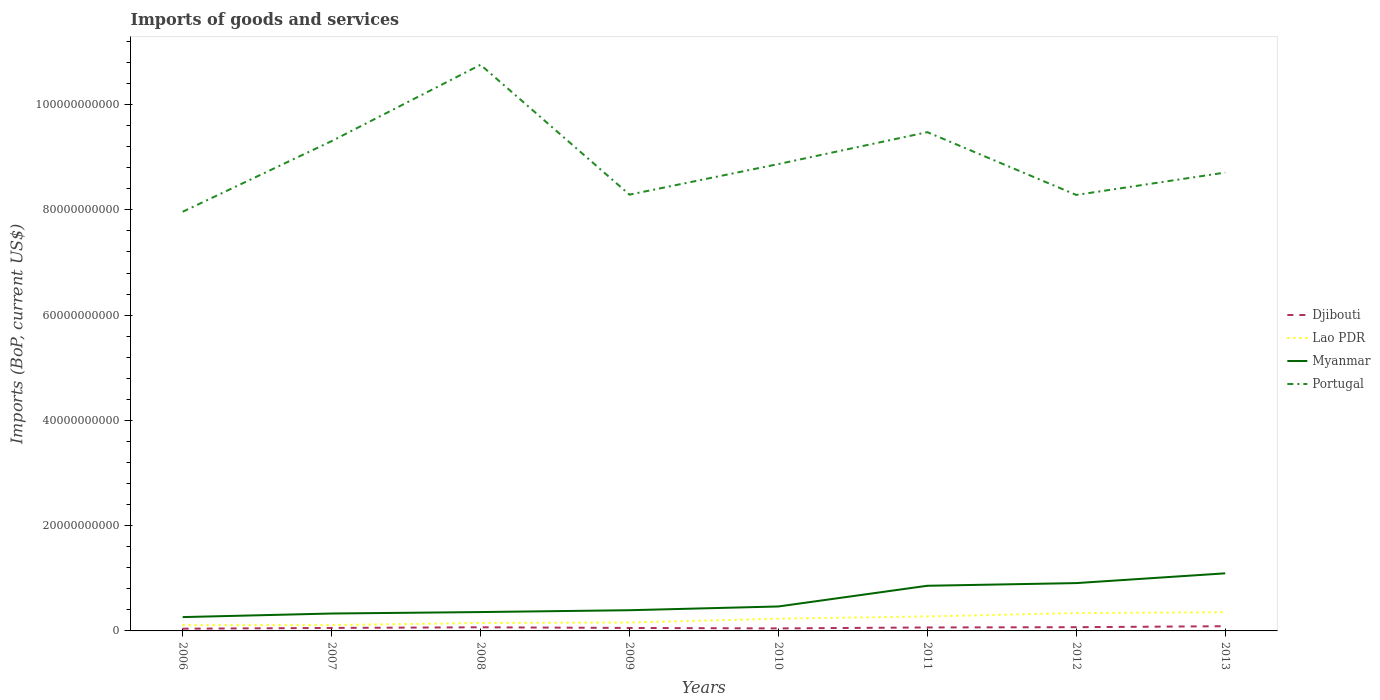How many different coloured lines are there?
Make the answer very short. 4. Does the line corresponding to Djibouti intersect with the line corresponding to Portugal?
Your response must be concise. No. Across all years, what is the maximum amount spent on imports in Portugal?
Offer a terse response. 7.96e+1. What is the total amount spent on imports in Lao PDR in the graph?
Provide a succinct answer. -2.46e+09. What is the difference between the highest and the second highest amount spent on imports in Djibouti?
Offer a terse response. 4.73e+08. What is the difference between the highest and the lowest amount spent on imports in Lao PDR?
Provide a succinct answer. 4. Is the amount spent on imports in Lao PDR strictly greater than the amount spent on imports in Portugal over the years?
Provide a short and direct response. Yes. How many lines are there?
Give a very brief answer. 4. How many years are there in the graph?
Offer a terse response. 8. What is the difference between two consecutive major ticks on the Y-axis?
Make the answer very short. 2.00e+1. Are the values on the major ticks of Y-axis written in scientific E-notation?
Give a very brief answer. No. Does the graph contain any zero values?
Provide a succinct answer. No. Where does the legend appear in the graph?
Offer a very short reply. Center right. How many legend labels are there?
Your response must be concise. 4. What is the title of the graph?
Offer a terse response. Imports of goods and services. Does "Isle of Man" appear as one of the legend labels in the graph?
Keep it short and to the point. No. What is the label or title of the Y-axis?
Provide a succinct answer. Imports (BoP, current US$). What is the Imports (BoP, current US$) of Djibouti in 2006?
Your answer should be compact. 4.25e+08. What is the Imports (BoP, current US$) of Lao PDR in 2006?
Ensure brevity in your answer.  1.10e+09. What is the Imports (BoP, current US$) of Myanmar in 2006?
Your answer should be compact. 2.63e+09. What is the Imports (BoP, current US$) in Portugal in 2006?
Offer a terse response. 7.96e+1. What is the Imports (BoP, current US$) in Djibouti in 2007?
Provide a succinct answer. 5.69e+08. What is the Imports (BoP, current US$) of Lao PDR in 2007?
Your answer should be very brief. 1.11e+09. What is the Imports (BoP, current US$) of Myanmar in 2007?
Make the answer very short. 3.31e+09. What is the Imports (BoP, current US$) in Portugal in 2007?
Your answer should be compact. 9.31e+1. What is the Imports (BoP, current US$) in Djibouti in 2008?
Your answer should be very brief. 6.91e+08. What is the Imports (BoP, current US$) of Lao PDR in 2008?
Offer a very short reply. 1.51e+09. What is the Imports (BoP, current US$) in Myanmar in 2008?
Your answer should be very brief. 3.58e+09. What is the Imports (BoP, current US$) of Portugal in 2008?
Offer a very short reply. 1.08e+11. What is the Imports (BoP, current US$) in Djibouti in 2009?
Make the answer very short. 5.65e+08. What is the Imports (BoP, current US$) in Lao PDR in 2009?
Your answer should be very brief. 1.60e+09. What is the Imports (BoP, current US$) of Myanmar in 2009?
Ensure brevity in your answer.  3.93e+09. What is the Imports (BoP, current US$) of Portugal in 2009?
Your response must be concise. 8.29e+1. What is the Imports (BoP, current US$) of Djibouti in 2010?
Keep it short and to the point. 4.78e+08. What is the Imports (BoP, current US$) in Lao PDR in 2010?
Ensure brevity in your answer.  2.32e+09. What is the Imports (BoP, current US$) of Myanmar in 2010?
Ensure brevity in your answer.  4.65e+09. What is the Imports (BoP, current US$) of Portugal in 2010?
Make the answer very short. 8.87e+1. What is the Imports (BoP, current US$) in Djibouti in 2011?
Keep it short and to the point. 6.58e+08. What is the Imports (BoP, current US$) in Lao PDR in 2011?
Keep it short and to the point. 2.75e+09. What is the Imports (BoP, current US$) of Myanmar in 2011?
Make the answer very short. 8.58e+09. What is the Imports (BoP, current US$) of Portugal in 2011?
Your response must be concise. 9.48e+1. What is the Imports (BoP, current US$) in Djibouti in 2012?
Give a very brief answer. 7.09e+08. What is the Imports (BoP, current US$) of Lao PDR in 2012?
Keep it short and to the point. 3.39e+09. What is the Imports (BoP, current US$) of Myanmar in 2012?
Offer a terse response. 9.09e+09. What is the Imports (BoP, current US$) of Portugal in 2012?
Offer a terse response. 8.28e+1. What is the Imports (BoP, current US$) of Djibouti in 2013?
Provide a short and direct response. 8.98e+08. What is the Imports (BoP, current US$) in Lao PDR in 2013?
Provide a short and direct response. 3.55e+09. What is the Imports (BoP, current US$) in Myanmar in 2013?
Ensure brevity in your answer.  1.09e+1. What is the Imports (BoP, current US$) in Portugal in 2013?
Provide a succinct answer. 8.71e+1. Across all years, what is the maximum Imports (BoP, current US$) of Djibouti?
Offer a very short reply. 8.98e+08. Across all years, what is the maximum Imports (BoP, current US$) of Lao PDR?
Make the answer very short. 3.55e+09. Across all years, what is the maximum Imports (BoP, current US$) in Myanmar?
Your answer should be compact. 1.09e+1. Across all years, what is the maximum Imports (BoP, current US$) in Portugal?
Provide a succinct answer. 1.08e+11. Across all years, what is the minimum Imports (BoP, current US$) of Djibouti?
Offer a terse response. 4.25e+08. Across all years, what is the minimum Imports (BoP, current US$) in Lao PDR?
Provide a succinct answer. 1.10e+09. Across all years, what is the minimum Imports (BoP, current US$) of Myanmar?
Offer a terse response. 2.63e+09. Across all years, what is the minimum Imports (BoP, current US$) of Portugal?
Give a very brief answer. 7.96e+1. What is the total Imports (BoP, current US$) in Djibouti in the graph?
Offer a very short reply. 4.99e+09. What is the total Imports (BoP, current US$) of Lao PDR in the graph?
Give a very brief answer. 1.73e+1. What is the total Imports (BoP, current US$) of Myanmar in the graph?
Provide a succinct answer. 4.67e+1. What is the total Imports (BoP, current US$) of Portugal in the graph?
Your answer should be very brief. 7.17e+11. What is the difference between the Imports (BoP, current US$) in Djibouti in 2006 and that in 2007?
Keep it short and to the point. -1.44e+08. What is the difference between the Imports (BoP, current US$) of Lao PDR in 2006 and that in 2007?
Keep it short and to the point. -1.08e+07. What is the difference between the Imports (BoP, current US$) of Myanmar in 2006 and that in 2007?
Your response must be concise. -6.80e+08. What is the difference between the Imports (BoP, current US$) of Portugal in 2006 and that in 2007?
Provide a short and direct response. -1.34e+1. What is the difference between the Imports (BoP, current US$) in Djibouti in 2006 and that in 2008?
Make the answer very short. -2.66e+08. What is the difference between the Imports (BoP, current US$) in Lao PDR in 2006 and that in 2008?
Ensure brevity in your answer.  -4.13e+08. What is the difference between the Imports (BoP, current US$) of Myanmar in 2006 and that in 2008?
Your answer should be compact. -9.56e+08. What is the difference between the Imports (BoP, current US$) of Portugal in 2006 and that in 2008?
Make the answer very short. -2.79e+1. What is the difference between the Imports (BoP, current US$) in Djibouti in 2006 and that in 2009?
Ensure brevity in your answer.  -1.40e+08. What is the difference between the Imports (BoP, current US$) of Lao PDR in 2006 and that in 2009?
Your answer should be compact. -4.99e+08. What is the difference between the Imports (BoP, current US$) in Myanmar in 2006 and that in 2009?
Offer a terse response. -1.31e+09. What is the difference between the Imports (BoP, current US$) of Portugal in 2006 and that in 2009?
Ensure brevity in your answer.  -3.25e+09. What is the difference between the Imports (BoP, current US$) of Djibouti in 2006 and that in 2010?
Make the answer very short. -5.34e+07. What is the difference between the Imports (BoP, current US$) of Lao PDR in 2006 and that in 2010?
Make the answer very short. -1.23e+09. What is the difference between the Imports (BoP, current US$) in Myanmar in 2006 and that in 2010?
Provide a succinct answer. -2.02e+09. What is the difference between the Imports (BoP, current US$) in Portugal in 2006 and that in 2010?
Your answer should be very brief. -9.06e+09. What is the difference between the Imports (BoP, current US$) in Djibouti in 2006 and that in 2011?
Offer a terse response. -2.33e+08. What is the difference between the Imports (BoP, current US$) in Lao PDR in 2006 and that in 2011?
Provide a succinct answer. -1.66e+09. What is the difference between the Imports (BoP, current US$) of Myanmar in 2006 and that in 2011?
Offer a terse response. -5.95e+09. What is the difference between the Imports (BoP, current US$) of Portugal in 2006 and that in 2011?
Ensure brevity in your answer.  -1.51e+1. What is the difference between the Imports (BoP, current US$) in Djibouti in 2006 and that in 2012?
Keep it short and to the point. -2.84e+08. What is the difference between the Imports (BoP, current US$) of Lao PDR in 2006 and that in 2012?
Provide a short and direct response. -2.30e+09. What is the difference between the Imports (BoP, current US$) of Myanmar in 2006 and that in 2012?
Make the answer very short. -6.46e+09. What is the difference between the Imports (BoP, current US$) in Portugal in 2006 and that in 2012?
Your response must be concise. -3.19e+09. What is the difference between the Imports (BoP, current US$) in Djibouti in 2006 and that in 2013?
Your answer should be very brief. -4.73e+08. What is the difference between the Imports (BoP, current US$) of Lao PDR in 2006 and that in 2013?
Keep it short and to the point. -2.46e+09. What is the difference between the Imports (BoP, current US$) in Myanmar in 2006 and that in 2013?
Ensure brevity in your answer.  -8.32e+09. What is the difference between the Imports (BoP, current US$) of Portugal in 2006 and that in 2013?
Make the answer very short. -7.44e+09. What is the difference between the Imports (BoP, current US$) of Djibouti in 2007 and that in 2008?
Make the answer very short. -1.22e+08. What is the difference between the Imports (BoP, current US$) in Lao PDR in 2007 and that in 2008?
Your answer should be compact. -4.03e+08. What is the difference between the Imports (BoP, current US$) in Myanmar in 2007 and that in 2008?
Offer a very short reply. -2.76e+08. What is the difference between the Imports (BoP, current US$) of Portugal in 2007 and that in 2008?
Give a very brief answer. -1.45e+1. What is the difference between the Imports (BoP, current US$) in Djibouti in 2007 and that in 2009?
Your answer should be very brief. 3.92e+06. What is the difference between the Imports (BoP, current US$) in Lao PDR in 2007 and that in 2009?
Your answer should be very brief. -4.88e+08. What is the difference between the Imports (BoP, current US$) of Myanmar in 2007 and that in 2009?
Give a very brief answer. -6.26e+08. What is the difference between the Imports (BoP, current US$) of Portugal in 2007 and that in 2009?
Offer a terse response. 1.02e+1. What is the difference between the Imports (BoP, current US$) in Djibouti in 2007 and that in 2010?
Offer a very short reply. 9.02e+07. What is the difference between the Imports (BoP, current US$) in Lao PDR in 2007 and that in 2010?
Make the answer very short. -1.22e+09. What is the difference between the Imports (BoP, current US$) of Myanmar in 2007 and that in 2010?
Make the answer very short. -1.34e+09. What is the difference between the Imports (BoP, current US$) in Portugal in 2007 and that in 2010?
Ensure brevity in your answer.  4.36e+09. What is the difference between the Imports (BoP, current US$) in Djibouti in 2007 and that in 2011?
Offer a very short reply. -8.98e+07. What is the difference between the Imports (BoP, current US$) in Lao PDR in 2007 and that in 2011?
Make the answer very short. -1.65e+09. What is the difference between the Imports (BoP, current US$) in Myanmar in 2007 and that in 2011?
Give a very brief answer. -5.27e+09. What is the difference between the Imports (BoP, current US$) of Portugal in 2007 and that in 2011?
Offer a terse response. -1.70e+09. What is the difference between the Imports (BoP, current US$) of Djibouti in 2007 and that in 2012?
Your answer should be compact. -1.40e+08. What is the difference between the Imports (BoP, current US$) in Lao PDR in 2007 and that in 2012?
Your answer should be compact. -2.29e+09. What is the difference between the Imports (BoP, current US$) in Myanmar in 2007 and that in 2012?
Make the answer very short. -5.78e+09. What is the difference between the Imports (BoP, current US$) of Portugal in 2007 and that in 2012?
Your answer should be compact. 1.02e+1. What is the difference between the Imports (BoP, current US$) in Djibouti in 2007 and that in 2013?
Offer a terse response. -3.29e+08. What is the difference between the Imports (BoP, current US$) in Lao PDR in 2007 and that in 2013?
Your answer should be very brief. -2.44e+09. What is the difference between the Imports (BoP, current US$) of Myanmar in 2007 and that in 2013?
Your response must be concise. -7.64e+09. What is the difference between the Imports (BoP, current US$) in Portugal in 2007 and that in 2013?
Provide a succinct answer. 5.98e+09. What is the difference between the Imports (BoP, current US$) of Djibouti in 2008 and that in 2009?
Provide a short and direct response. 1.26e+08. What is the difference between the Imports (BoP, current US$) of Lao PDR in 2008 and that in 2009?
Give a very brief answer. -8.56e+07. What is the difference between the Imports (BoP, current US$) of Myanmar in 2008 and that in 2009?
Provide a succinct answer. -3.50e+08. What is the difference between the Imports (BoP, current US$) of Portugal in 2008 and that in 2009?
Your answer should be compact. 2.47e+1. What is the difference between the Imports (BoP, current US$) of Djibouti in 2008 and that in 2010?
Ensure brevity in your answer.  2.12e+08. What is the difference between the Imports (BoP, current US$) of Lao PDR in 2008 and that in 2010?
Give a very brief answer. -8.12e+08. What is the difference between the Imports (BoP, current US$) of Myanmar in 2008 and that in 2010?
Provide a short and direct response. -1.06e+09. What is the difference between the Imports (BoP, current US$) of Portugal in 2008 and that in 2010?
Offer a very short reply. 1.89e+1. What is the difference between the Imports (BoP, current US$) of Djibouti in 2008 and that in 2011?
Your response must be concise. 3.23e+07. What is the difference between the Imports (BoP, current US$) of Lao PDR in 2008 and that in 2011?
Ensure brevity in your answer.  -1.24e+09. What is the difference between the Imports (BoP, current US$) in Myanmar in 2008 and that in 2011?
Provide a short and direct response. -5.00e+09. What is the difference between the Imports (BoP, current US$) of Portugal in 2008 and that in 2011?
Ensure brevity in your answer.  1.28e+1. What is the difference between the Imports (BoP, current US$) in Djibouti in 2008 and that in 2012?
Offer a terse response. -1.84e+07. What is the difference between the Imports (BoP, current US$) of Lao PDR in 2008 and that in 2012?
Ensure brevity in your answer.  -1.88e+09. What is the difference between the Imports (BoP, current US$) in Myanmar in 2008 and that in 2012?
Give a very brief answer. -5.51e+09. What is the difference between the Imports (BoP, current US$) in Portugal in 2008 and that in 2012?
Ensure brevity in your answer.  2.47e+1. What is the difference between the Imports (BoP, current US$) of Djibouti in 2008 and that in 2013?
Offer a very short reply. -2.07e+08. What is the difference between the Imports (BoP, current US$) in Lao PDR in 2008 and that in 2013?
Your response must be concise. -2.04e+09. What is the difference between the Imports (BoP, current US$) in Myanmar in 2008 and that in 2013?
Your answer should be compact. -7.36e+09. What is the difference between the Imports (BoP, current US$) in Portugal in 2008 and that in 2013?
Your response must be concise. 2.05e+1. What is the difference between the Imports (BoP, current US$) of Djibouti in 2009 and that in 2010?
Offer a terse response. 8.62e+07. What is the difference between the Imports (BoP, current US$) in Lao PDR in 2009 and that in 2010?
Provide a short and direct response. -7.27e+08. What is the difference between the Imports (BoP, current US$) in Myanmar in 2009 and that in 2010?
Make the answer very short. -7.14e+08. What is the difference between the Imports (BoP, current US$) of Portugal in 2009 and that in 2010?
Keep it short and to the point. -5.81e+09. What is the difference between the Imports (BoP, current US$) in Djibouti in 2009 and that in 2011?
Provide a short and direct response. -9.37e+07. What is the difference between the Imports (BoP, current US$) of Lao PDR in 2009 and that in 2011?
Make the answer very short. -1.16e+09. What is the difference between the Imports (BoP, current US$) in Myanmar in 2009 and that in 2011?
Provide a succinct answer. -4.65e+09. What is the difference between the Imports (BoP, current US$) of Portugal in 2009 and that in 2011?
Provide a short and direct response. -1.19e+1. What is the difference between the Imports (BoP, current US$) in Djibouti in 2009 and that in 2012?
Provide a succinct answer. -1.44e+08. What is the difference between the Imports (BoP, current US$) in Lao PDR in 2009 and that in 2012?
Make the answer very short. -1.80e+09. What is the difference between the Imports (BoP, current US$) in Myanmar in 2009 and that in 2012?
Offer a very short reply. -5.16e+09. What is the difference between the Imports (BoP, current US$) in Portugal in 2009 and that in 2012?
Your answer should be very brief. 5.46e+07. What is the difference between the Imports (BoP, current US$) in Djibouti in 2009 and that in 2013?
Your answer should be very brief. -3.33e+08. What is the difference between the Imports (BoP, current US$) in Lao PDR in 2009 and that in 2013?
Keep it short and to the point. -1.96e+09. What is the difference between the Imports (BoP, current US$) of Myanmar in 2009 and that in 2013?
Your response must be concise. -7.01e+09. What is the difference between the Imports (BoP, current US$) of Portugal in 2009 and that in 2013?
Provide a short and direct response. -4.20e+09. What is the difference between the Imports (BoP, current US$) of Djibouti in 2010 and that in 2011?
Provide a succinct answer. -1.80e+08. What is the difference between the Imports (BoP, current US$) of Lao PDR in 2010 and that in 2011?
Provide a succinct answer. -4.30e+08. What is the difference between the Imports (BoP, current US$) of Myanmar in 2010 and that in 2011?
Give a very brief answer. -3.93e+09. What is the difference between the Imports (BoP, current US$) of Portugal in 2010 and that in 2011?
Offer a terse response. -6.06e+09. What is the difference between the Imports (BoP, current US$) of Djibouti in 2010 and that in 2012?
Offer a very short reply. -2.31e+08. What is the difference between the Imports (BoP, current US$) in Lao PDR in 2010 and that in 2012?
Your response must be concise. -1.07e+09. What is the difference between the Imports (BoP, current US$) in Myanmar in 2010 and that in 2012?
Offer a very short reply. -4.44e+09. What is the difference between the Imports (BoP, current US$) of Portugal in 2010 and that in 2012?
Offer a very short reply. 5.87e+09. What is the difference between the Imports (BoP, current US$) of Djibouti in 2010 and that in 2013?
Keep it short and to the point. -4.19e+08. What is the difference between the Imports (BoP, current US$) of Lao PDR in 2010 and that in 2013?
Give a very brief answer. -1.23e+09. What is the difference between the Imports (BoP, current US$) of Myanmar in 2010 and that in 2013?
Offer a terse response. -6.30e+09. What is the difference between the Imports (BoP, current US$) of Portugal in 2010 and that in 2013?
Ensure brevity in your answer.  1.62e+09. What is the difference between the Imports (BoP, current US$) of Djibouti in 2011 and that in 2012?
Ensure brevity in your answer.  -5.07e+07. What is the difference between the Imports (BoP, current US$) of Lao PDR in 2011 and that in 2012?
Provide a short and direct response. -6.41e+08. What is the difference between the Imports (BoP, current US$) in Myanmar in 2011 and that in 2012?
Your answer should be very brief. -5.07e+08. What is the difference between the Imports (BoP, current US$) in Portugal in 2011 and that in 2012?
Offer a terse response. 1.19e+1. What is the difference between the Imports (BoP, current US$) of Djibouti in 2011 and that in 2013?
Provide a succinct answer. -2.39e+08. What is the difference between the Imports (BoP, current US$) in Lao PDR in 2011 and that in 2013?
Give a very brief answer. -8.00e+08. What is the difference between the Imports (BoP, current US$) of Myanmar in 2011 and that in 2013?
Your answer should be very brief. -2.36e+09. What is the difference between the Imports (BoP, current US$) of Portugal in 2011 and that in 2013?
Your answer should be very brief. 7.68e+09. What is the difference between the Imports (BoP, current US$) in Djibouti in 2012 and that in 2013?
Your answer should be compact. -1.88e+08. What is the difference between the Imports (BoP, current US$) in Lao PDR in 2012 and that in 2013?
Offer a very short reply. -1.59e+08. What is the difference between the Imports (BoP, current US$) in Myanmar in 2012 and that in 2013?
Ensure brevity in your answer.  -1.86e+09. What is the difference between the Imports (BoP, current US$) in Portugal in 2012 and that in 2013?
Offer a terse response. -4.25e+09. What is the difference between the Imports (BoP, current US$) in Djibouti in 2006 and the Imports (BoP, current US$) in Lao PDR in 2007?
Your answer should be compact. -6.83e+08. What is the difference between the Imports (BoP, current US$) of Djibouti in 2006 and the Imports (BoP, current US$) of Myanmar in 2007?
Provide a short and direct response. -2.88e+09. What is the difference between the Imports (BoP, current US$) of Djibouti in 2006 and the Imports (BoP, current US$) of Portugal in 2007?
Offer a very short reply. -9.26e+1. What is the difference between the Imports (BoP, current US$) in Lao PDR in 2006 and the Imports (BoP, current US$) in Myanmar in 2007?
Your response must be concise. -2.21e+09. What is the difference between the Imports (BoP, current US$) in Lao PDR in 2006 and the Imports (BoP, current US$) in Portugal in 2007?
Make the answer very short. -9.20e+1. What is the difference between the Imports (BoP, current US$) of Myanmar in 2006 and the Imports (BoP, current US$) of Portugal in 2007?
Your answer should be very brief. -9.04e+1. What is the difference between the Imports (BoP, current US$) in Djibouti in 2006 and the Imports (BoP, current US$) in Lao PDR in 2008?
Your answer should be compact. -1.09e+09. What is the difference between the Imports (BoP, current US$) in Djibouti in 2006 and the Imports (BoP, current US$) in Myanmar in 2008?
Give a very brief answer. -3.16e+09. What is the difference between the Imports (BoP, current US$) in Djibouti in 2006 and the Imports (BoP, current US$) in Portugal in 2008?
Offer a terse response. -1.07e+11. What is the difference between the Imports (BoP, current US$) of Lao PDR in 2006 and the Imports (BoP, current US$) of Myanmar in 2008?
Ensure brevity in your answer.  -2.49e+09. What is the difference between the Imports (BoP, current US$) of Lao PDR in 2006 and the Imports (BoP, current US$) of Portugal in 2008?
Your response must be concise. -1.06e+11. What is the difference between the Imports (BoP, current US$) in Myanmar in 2006 and the Imports (BoP, current US$) in Portugal in 2008?
Provide a short and direct response. -1.05e+11. What is the difference between the Imports (BoP, current US$) of Djibouti in 2006 and the Imports (BoP, current US$) of Lao PDR in 2009?
Your response must be concise. -1.17e+09. What is the difference between the Imports (BoP, current US$) of Djibouti in 2006 and the Imports (BoP, current US$) of Myanmar in 2009?
Keep it short and to the point. -3.51e+09. What is the difference between the Imports (BoP, current US$) in Djibouti in 2006 and the Imports (BoP, current US$) in Portugal in 2009?
Your answer should be compact. -8.25e+1. What is the difference between the Imports (BoP, current US$) of Lao PDR in 2006 and the Imports (BoP, current US$) of Myanmar in 2009?
Ensure brevity in your answer.  -2.83e+09. What is the difference between the Imports (BoP, current US$) of Lao PDR in 2006 and the Imports (BoP, current US$) of Portugal in 2009?
Provide a succinct answer. -8.18e+1. What is the difference between the Imports (BoP, current US$) in Myanmar in 2006 and the Imports (BoP, current US$) in Portugal in 2009?
Your answer should be compact. -8.03e+1. What is the difference between the Imports (BoP, current US$) of Djibouti in 2006 and the Imports (BoP, current US$) of Lao PDR in 2010?
Make the answer very short. -1.90e+09. What is the difference between the Imports (BoP, current US$) in Djibouti in 2006 and the Imports (BoP, current US$) in Myanmar in 2010?
Offer a terse response. -4.22e+09. What is the difference between the Imports (BoP, current US$) in Djibouti in 2006 and the Imports (BoP, current US$) in Portugal in 2010?
Make the answer very short. -8.83e+1. What is the difference between the Imports (BoP, current US$) of Lao PDR in 2006 and the Imports (BoP, current US$) of Myanmar in 2010?
Ensure brevity in your answer.  -3.55e+09. What is the difference between the Imports (BoP, current US$) in Lao PDR in 2006 and the Imports (BoP, current US$) in Portugal in 2010?
Provide a short and direct response. -8.76e+1. What is the difference between the Imports (BoP, current US$) of Myanmar in 2006 and the Imports (BoP, current US$) of Portugal in 2010?
Your answer should be very brief. -8.61e+1. What is the difference between the Imports (BoP, current US$) of Djibouti in 2006 and the Imports (BoP, current US$) of Lao PDR in 2011?
Keep it short and to the point. -2.33e+09. What is the difference between the Imports (BoP, current US$) in Djibouti in 2006 and the Imports (BoP, current US$) in Myanmar in 2011?
Give a very brief answer. -8.16e+09. What is the difference between the Imports (BoP, current US$) of Djibouti in 2006 and the Imports (BoP, current US$) of Portugal in 2011?
Ensure brevity in your answer.  -9.43e+1. What is the difference between the Imports (BoP, current US$) of Lao PDR in 2006 and the Imports (BoP, current US$) of Myanmar in 2011?
Your response must be concise. -7.48e+09. What is the difference between the Imports (BoP, current US$) of Lao PDR in 2006 and the Imports (BoP, current US$) of Portugal in 2011?
Offer a terse response. -9.37e+1. What is the difference between the Imports (BoP, current US$) in Myanmar in 2006 and the Imports (BoP, current US$) in Portugal in 2011?
Your answer should be very brief. -9.21e+1. What is the difference between the Imports (BoP, current US$) in Djibouti in 2006 and the Imports (BoP, current US$) in Lao PDR in 2012?
Give a very brief answer. -2.97e+09. What is the difference between the Imports (BoP, current US$) in Djibouti in 2006 and the Imports (BoP, current US$) in Myanmar in 2012?
Make the answer very short. -8.66e+09. What is the difference between the Imports (BoP, current US$) in Djibouti in 2006 and the Imports (BoP, current US$) in Portugal in 2012?
Provide a short and direct response. -8.24e+1. What is the difference between the Imports (BoP, current US$) in Lao PDR in 2006 and the Imports (BoP, current US$) in Myanmar in 2012?
Offer a very short reply. -7.99e+09. What is the difference between the Imports (BoP, current US$) of Lao PDR in 2006 and the Imports (BoP, current US$) of Portugal in 2012?
Offer a very short reply. -8.17e+1. What is the difference between the Imports (BoP, current US$) in Myanmar in 2006 and the Imports (BoP, current US$) in Portugal in 2012?
Provide a succinct answer. -8.02e+1. What is the difference between the Imports (BoP, current US$) of Djibouti in 2006 and the Imports (BoP, current US$) of Lao PDR in 2013?
Keep it short and to the point. -3.13e+09. What is the difference between the Imports (BoP, current US$) in Djibouti in 2006 and the Imports (BoP, current US$) in Myanmar in 2013?
Your answer should be compact. -1.05e+1. What is the difference between the Imports (BoP, current US$) in Djibouti in 2006 and the Imports (BoP, current US$) in Portugal in 2013?
Your answer should be very brief. -8.67e+1. What is the difference between the Imports (BoP, current US$) in Lao PDR in 2006 and the Imports (BoP, current US$) in Myanmar in 2013?
Offer a terse response. -9.85e+09. What is the difference between the Imports (BoP, current US$) in Lao PDR in 2006 and the Imports (BoP, current US$) in Portugal in 2013?
Ensure brevity in your answer.  -8.60e+1. What is the difference between the Imports (BoP, current US$) of Myanmar in 2006 and the Imports (BoP, current US$) of Portugal in 2013?
Your answer should be very brief. -8.45e+1. What is the difference between the Imports (BoP, current US$) of Djibouti in 2007 and the Imports (BoP, current US$) of Lao PDR in 2008?
Make the answer very short. -9.42e+08. What is the difference between the Imports (BoP, current US$) of Djibouti in 2007 and the Imports (BoP, current US$) of Myanmar in 2008?
Your answer should be very brief. -3.01e+09. What is the difference between the Imports (BoP, current US$) of Djibouti in 2007 and the Imports (BoP, current US$) of Portugal in 2008?
Your response must be concise. -1.07e+11. What is the difference between the Imports (BoP, current US$) of Lao PDR in 2007 and the Imports (BoP, current US$) of Myanmar in 2008?
Make the answer very short. -2.47e+09. What is the difference between the Imports (BoP, current US$) in Lao PDR in 2007 and the Imports (BoP, current US$) in Portugal in 2008?
Make the answer very short. -1.06e+11. What is the difference between the Imports (BoP, current US$) of Myanmar in 2007 and the Imports (BoP, current US$) of Portugal in 2008?
Ensure brevity in your answer.  -1.04e+11. What is the difference between the Imports (BoP, current US$) of Djibouti in 2007 and the Imports (BoP, current US$) of Lao PDR in 2009?
Keep it short and to the point. -1.03e+09. What is the difference between the Imports (BoP, current US$) in Djibouti in 2007 and the Imports (BoP, current US$) in Myanmar in 2009?
Your answer should be compact. -3.36e+09. What is the difference between the Imports (BoP, current US$) in Djibouti in 2007 and the Imports (BoP, current US$) in Portugal in 2009?
Offer a very short reply. -8.23e+1. What is the difference between the Imports (BoP, current US$) of Lao PDR in 2007 and the Imports (BoP, current US$) of Myanmar in 2009?
Keep it short and to the point. -2.82e+09. What is the difference between the Imports (BoP, current US$) of Lao PDR in 2007 and the Imports (BoP, current US$) of Portugal in 2009?
Offer a terse response. -8.18e+1. What is the difference between the Imports (BoP, current US$) in Myanmar in 2007 and the Imports (BoP, current US$) in Portugal in 2009?
Offer a very short reply. -7.96e+1. What is the difference between the Imports (BoP, current US$) in Djibouti in 2007 and the Imports (BoP, current US$) in Lao PDR in 2010?
Offer a very short reply. -1.75e+09. What is the difference between the Imports (BoP, current US$) of Djibouti in 2007 and the Imports (BoP, current US$) of Myanmar in 2010?
Offer a very short reply. -4.08e+09. What is the difference between the Imports (BoP, current US$) of Djibouti in 2007 and the Imports (BoP, current US$) of Portugal in 2010?
Your response must be concise. -8.81e+1. What is the difference between the Imports (BoP, current US$) in Lao PDR in 2007 and the Imports (BoP, current US$) in Myanmar in 2010?
Your answer should be compact. -3.54e+09. What is the difference between the Imports (BoP, current US$) of Lao PDR in 2007 and the Imports (BoP, current US$) of Portugal in 2010?
Make the answer very short. -8.76e+1. What is the difference between the Imports (BoP, current US$) in Myanmar in 2007 and the Imports (BoP, current US$) in Portugal in 2010?
Your answer should be compact. -8.54e+1. What is the difference between the Imports (BoP, current US$) in Djibouti in 2007 and the Imports (BoP, current US$) in Lao PDR in 2011?
Make the answer very short. -2.18e+09. What is the difference between the Imports (BoP, current US$) in Djibouti in 2007 and the Imports (BoP, current US$) in Myanmar in 2011?
Offer a terse response. -8.01e+09. What is the difference between the Imports (BoP, current US$) in Djibouti in 2007 and the Imports (BoP, current US$) in Portugal in 2011?
Make the answer very short. -9.42e+1. What is the difference between the Imports (BoP, current US$) of Lao PDR in 2007 and the Imports (BoP, current US$) of Myanmar in 2011?
Give a very brief answer. -7.47e+09. What is the difference between the Imports (BoP, current US$) in Lao PDR in 2007 and the Imports (BoP, current US$) in Portugal in 2011?
Ensure brevity in your answer.  -9.37e+1. What is the difference between the Imports (BoP, current US$) of Myanmar in 2007 and the Imports (BoP, current US$) of Portugal in 2011?
Provide a short and direct response. -9.15e+1. What is the difference between the Imports (BoP, current US$) in Djibouti in 2007 and the Imports (BoP, current US$) in Lao PDR in 2012?
Keep it short and to the point. -2.83e+09. What is the difference between the Imports (BoP, current US$) in Djibouti in 2007 and the Imports (BoP, current US$) in Myanmar in 2012?
Provide a succinct answer. -8.52e+09. What is the difference between the Imports (BoP, current US$) of Djibouti in 2007 and the Imports (BoP, current US$) of Portugal in 2012?
Provide a succinct answer. -8.23e+1. What is the difference between the Imports (BoP, current US$) of Lao PDR in 2007 and the Imports (BoP, current US$) of Myanmar in 2012?
Provide a short and direct response. -7.98e+09. What is the difference between the Imports (BoP, current US$) in Lao PDR in 2007 and the Imports (BoP, current US$) in Portugal in 2012?
Offer a very short reply. -8.17e+1. What is the difference between the Imports (BoP, current US$) of Myanmar in 2007 and the Imports (BoP, current US$) of Portugal in 2012?
Make the answer very short. -7.95e+1. What is the difference between the Imports (BoP, current US$) in Djibouti in 2007 and the Imports (BoP, current US$) in Lao PDR in 2013?
Your answer should be very brief. -2.98e+09. What is the difference between the Imports (BoP, current US$) in Djibouti in 2007 and the Imports (BoP, current US$) in Myanmar in 2013?
Keep it short and to the point. -1.04e+1. What is the difference between the Imports (BoP, current US$) in Djibouti in 2007 and the Imports (BoP, current US$) in Portugal in 2013?
Provide a succinct answer. -8.65e+1. What is the difference between the Imports (BoP, current US$) in Lao PDR in 2007 and the Imports (BoP, current US$) in Myanmar in 2013?
Your response must be concise. -9.83e+09. What is the difference between the Imports (BoP, current US$) of Lao PDR in 2007 and the Imports (BoP, current US$) of Portugal in 2013?
Give a very brief answer. -8.60e+1. What is the difference between the Imports (BoP, current US$) of Myanmar in 2007 and the Imports (BoP, current US$) of Portugal in 2013?
Give a very brief answer. -8.38e+1. What is the difference between the Imports (BoP, current US$) in Djibouti in 2008 and the Imports (BoP, current US$) in Lao PDR in 2009?
Provide a short and direct response. -9.06e+08. What is the difference between the Imports (BoP, current US$) of Djibouti in 2008 and the Imports (BoP, current US$) of Myanmar in 2009?
Keep it short and to the point. -3.24e+09. What is the difference between the Imports (BoP, current US$) in Djibouti in 2008 and the Imports (BoP, current US$) in Portugal in 2009?
Your response must be concise. -8.22e+1. What is the difference between the Imports (BoP, current US$) in Lao PDR in 2008 and the Imports (BoP, current US$) in Myanmar in 2009?
Keep it short and to the point. -2.42e+09. What is the difference between the Imports (BoP, current US$) in Lao PDR in 2008 and the Imports (BoP, current US$) in Portugal in 2009?
Make the answer very short. -8.14e+1. What is the difference between the Imports (BoP, current US$) in Myanmar in 2008 and the Imports (BoP, current US$) in Portugal in 2009?
Give a very brief answer. -7.93e+1. What is the difference between the Imports (BoP, current US$) in Djibouti in 2008 and the Imports (BoP, current US$) in Lao PDR in 2010?
Give a very brief answer. -1.63e+09. What is the difference between the Imports (BoP, current US$) in Djibouti in 2008 and the Imports (BoP, current US$) in Myanmar in 2010?
Provide a short and direct response. -3.96e+09. What is the difference between the Imports (BoP, current US$) of Djibouti in 2008 and the Imports (BoP, current US$) of Portugal in 2010?
Make the answer very short. -8.80e+1. What is the difference between the Imports (BoP, current US$) of Lao PDR in 2008 and the Imports (BoP, current US$) of Myanmar in 2010?
Offer a very short reply. -3.14e+09. What is the difference between the Imports (BoP, current US$) of Lao PDR in 2008 and the Imports (BoP, current US$) of Portugal in 2010?
Provide a short and direct response. -8.72e+1. What is the difference between the Imports (BoP, current US$) in Myanmar in 2008 and the Imports (BoP, current US$) in Portugal in 2010?
Keep it short and to the point. -8.51e+1. What is the difference between the Imports (BoP, current US$) of Djibouti in 2008 and the Imports (BoP, current US$) of Lao PDR in 2011?
Make the answer very short. -2.06e+09. What is the difference between the Imports (BoP, current US$) in Djibouti in 2008 and the Imports (BoP, current US$) in Myanmar in 2011?
Provide a short and direct response. -7.89e+09. What is the difference between the Imports (BoP, current US$) of Djibouti in 2008 and the Imports (BoP, current US$) of Portugal in 2011?
Your response must be concise. -9.41e+1. What is the difference between the Imports (BoP, current US$) of Lao PDR in 2008 and the Imports (BoP, current US$) of Myanmar in 2011?
Offer a very short reply. -7.07e+09. What is the difference between the Imports (BoP, current US$) in Lao PDR in 2008 and the Imports (BoP, current US$) in Portugal in 2011?
Make the answer very short. -9.33e+1. What is the difference between the Imports (BoP, current US$) of Myanmar in 2008 and the Imports (BoP, current US$) of Portugal in 2011?
Your answer should be very brief. -9.12e+1. What is the difference between the Imports (BoP, current US$) in Djibouti in 2008 and the Imports (BoP, current US$) in Lao PDR in 2012?
Offer a very short reply. -2.70e+09. What is the difference between the Imports (BoP, current US$) in Djibouti in 2008 and the Imports (BoP, current US$) in Myanmar in 2012?
Make the answer very short. -8.40e+09. What is the difference between the Imports (BoP, current US$) in Djibouti in 2008 and the Imports (BoP, current US$) in Portugal in 2012?
Ensure brevity in your answer.  -8.22e+1. What is the difference between the Imports (BoP, current US$) in Lao PDR in 2008 and the Imports (BoP, current US$) in Myanmar in 2012?
Provide a succinct answer. -7.58e+09. What is the difference between the Imports (BoP, current US$) of Lao PDR in 2008 and the Imports (BoP, current US$) of Portugal in 2012?
Provide a short and direct response. -8.13e+1. What is the difference between the Imports (BoP, current US$) in Myanmar in 2008 and the Imports (BoP, current US$) in Portugal in 2012?
Your answer should be very brief. -7.93e+1. What is the difference between the Imports (BoP, current US$) in Djibouti in 2008 and the Imports (BoP, current US$) in Lao PDR in 2013?
Keep it short and to the point. -2.86e+09. What is the difference between the Imports (BoP, current US$) of Djibouti in 2008 and the Imports (BoP, current US$) of Myanmar in 2013?
Provide a short and direct response. -1.03e+1. What is the difference between the Imports (BoP, current US$) in Djibouti in 2008 and the Imports (BoP, current US$) in Portugal in 2013?
Make the answer very short. -8.64e+1. What is the difference between the Imports (BoP, current US$) in Lao PDR in 2008 and the Imports (BoP, current US$) in Myanmar in 2013?
Provide a short and direct response. -9.43e+09. What is the difference between the Imports (BoP, current US$) of Lao PDR in 2008 and the Imports (BoP, current US$) of Portugal in 2013?
Your answer should be very brief. -8.56e+1. What is the difference between the Imports (BoP, current US$) in Myanmar in 2008 and the Imports (BoP, current US$) in Portugal in 2013?
Offer a very short reply. -8.35e+1. What is the difference between the Imports (BoP, current US$) in Djibouti in 2009 and the Imports (BoP, current US$) in Lao PDR in 2010?
Keep it short and to the point. -1.76e+09. What is the difference between the Imports (BoP, current US$) of Djibouti in 2009 and the Imports (BoP, current US$) of Myanmar in 2010?
Offer a terse response. -4.08e+09. What is the difference between the Imports (BoP, current US$) of Djibouti in 2009 and the Imports (BoP, current US$) of Portugal in 2010?
Give a very brief answer. -8.81e+1. What is the difference between the Imports (BoP, current US$) in Lao PDR in 2009 and the Imports (BoP, current US$) in Myanmar in 2010?
Make the answer very short. -3.05e+09. What is the difference between the Imports (BoP, current US$) in Lao PDR in 2009 and the Imports (BoP, current US$) in Portugal in 2010?
Provide a short and direct response. -8.71e+1. What is the difference between the Imports (BoP, current US$) in Myanmar in 2009 and the Imports (BoP, current US$) in Portugal in 2010?
Give a very brief answer. -8.48e+1. What is the difference between the Imports (BoP, current US$) in Djibouti in 2009 and the Imports (BoP, current US$) in Lao PDR in 2011?
Keep it short and to the point. -2.19e+09. What is the difference between the Imports (BoP, current US$) of Djibouti in 2009 and the Imports (BoP, current US$) of Myanmar in 2011?
Give a very brief answer. -8.02e+09. What is the difference between the Imports (BoP, current US$) in Djibouti in 2009 and the Imports (BoP, current US$) in Portugal in 2011?
Your answer should be very brief. -9.42e+1. What is the difference between the Imports (BoP, current US$) in Lao PDR in 2009 and the Imports (BoP, current US$) in Myanmar in 2011?
Keep it short and to the point. -6.98e+09. What is the difference between the Imports (BoP, current US$) in Lao PDR in 2009 and the Imports (BoP, current US$) in Portugal in 2011?
Keep it short and to the point. -9.32e+1. What is the difference between the Imports (BoP, current US$) of Myanmar in 2009 and the Imports (BoP, current US$) of Portugal in 2011?
Offer a terse response. -9.08e+1. What is the difference between the Imports (BoP, current US$) of Djibouti in 2009 and the Imports (BoP, current US$) of Lao PDR in 2012?
Your answer should be compact. -2.83e+09. What is the difference between the Imports (BoP, current US$) of Djibouti in 2009 and the Imports (BoP, current US$) of Myanmar in 2012?
Your response must be concise. -8.52e+09. What is the difference between the Imports (BoP, current US$) in Djibouti in 2009 and the Imports (BoP, current US$) in Portugal in 2012?
Your answer should be very brief. -8.23e+1. What is the difference between the Imports (BoP, current US$) of Lao PDR in 2009 and the Imports (BoP, current US$) of Myanmar in 2012?
Offer a terse response. -7.49e+09. What is the difference between the Imports (BoP, current US$) of Lao PDR in 2009 and the Imports (BoP, current US$) of Portugal in 2012?
Provide a short and direct response. -8.12e+1. What is the difference between the Imports (BoP, current US$) of Myanmar in 2009 and the Imports (BoP, current US$) of Portugal in 2012?
Ensure brevity in your answer.  -7.89e+1. What is the difference between the Imports (BoP, current US$) of Djibouti in 2009 and the Imports (BoP, current US$) of Lao PDR in 2013?
Provide a succinct answer. -2.99e+09. What is the difference between the Imports (BoP, current US$) of Djibouti in 2009 and the Imports (BoP, current US$) of Myanmar in 2013?
Provide a succinct answer. -1.04e+1. What is the difference between the Imports (BoP, current US$) in Djibouti in 2009 and the Imports (BoP, current US$) in Portugal in 2013?
Offer a terse response. -8.65e+1. What is the difference between the Imports (BoP, current US$) of Lao PDR in 2009 and the Imports (BoP, current US$) of Myanmar in 2013?
Offer a very short reply. -9.35e+09. What is the difference between the Imports (BoP, current US$) in Lao PDR in 2009 and the Imports (BoP, current US$) in Portugal in 2013?
Provide a succinct answer. -8.55e+1. What is the difference between the Imports (BoP, current US$) in Myanmar in 2009 and the Imports (BoP, current US$) in Portugal in 2013?
Keep it short and to the point. -8.32e+1. What is the difference between the Imports (BoP, current US$) in Djibouti in 2010 and the Imports (BoP, current US$) in Lao PDR in 2011?
Offer a very short reply. -2.28e+09. What is the difference between the Imports (BoP, current US$) in Djibouti in 2010 and the Imports (BoP, current US$) in Myanmar in 2011?
Provide a short and direct response. -8.10e+09. What is the difference between the Imports (BoP, current US$) of Djibouti in 2010 and the Imports (BoP, current US$) of Portugal in 2011?
Keep it short and to the point. -9.43e+1. What is the difference between the Imports (BoP, current US$) in Lao PDR in 2010 and the Imports (BoP, current US$) in Myanmar in 2011?
Your response must be concise. -6.26e+09. What is the difference between the Imports (BoP, current US$) of Lao PDR in 2010 and the Imports (BoP, current US$) of Portugal in 2011?
Offer a very short reply. -9.24e+1. What is the difference between the Imports (BoP, current US$) of Myanmar in 2010 and the Imports (BoP, current US$) of Portugal in 2011?
Your answer should be compact. -9.01e+1. What is the difference between the Imports (BoP, current US$) of Djibouti in 2010 and the Imports (BoP, current US$) of Lao PDR in 2012?
Give a very brief answer. -2.92e+09. What is the difference between the Imports (BoP, current US$) of Djibouti in 2010 and the Imports (BoP, current US$) of Myanmar in 2012?
Your response must be concise. -8.61e+09. What is the difference between the Imports (BoP, current US$) of Djibouti in 2010 and the Imports (BoP, current US$) of Portugal in 2012?
Offer a very short reply. -8.24e+1. What is the difference between the Imports (BoP, current US$) of Lao PDR in 2010 and the Imports (BoP, current US$) of Myanmar in 2012?
Your response must be concise. -6.76e+09. What is the difference between the Imports (BoP, current US$) of Lao PDR in 2010 and the Imports (BoP, current US$) of Portugal in 2012?
Your response must be concise. -8.05e+1. What is the difference between the Imports (BoP, current US$) of Myanmar in 2010 and the Imports (BoP, current US$) of Portugal in 2012?
Your response must be concise. -7.82e+1. What is the difference between the Imports (BoP, current US$) in Djibouti in 2010 and the Imports (BoP, current US$) in Lao PDR in 2013?
Provide a succinct answer. -3.08e+09. What is the difference between the Imports (BoP, current US$) in Djibouti in 2010 and the Imports (BoP, current US$) in Myanmar in 2013?
Ensure brevity in your answer.  -1.05e+1. What is the difference between the Imports (BoP, current US$) of Djibouti in 2010 and the Imports (BoP, current US$) of Portugal in 2013?
Provide a short and direct response. -8.66e+1. What is the difference between the Imports (BoP, current US$) of Lao PDR in 2010 and the Imports (BoP, current US$) of Myanmar in 2013?
Your response must be concise. -8.62e+09. What is the difference between the Imports (BoP, current US$) in Lao PDR in 2010 and the Imports (BoP, current US$) in Portugal in 2013?
Your answer should be very brief. -8.48e+1. What is the difference between the Imports (BoP, current US$) in Myanmar in 2010 and the Imports (BoP, current US$) in Portugal in 2013?
Your answer should be very brief. -8.24e+1. What is the difference between the Imports (BoP, current US$) in Djibouti in 2011 and the Imports (BoP, current US$) in Lao PDR in 2012?
Offer a terse response. -2.74e+09. What is the difference between the Imports (BoP, current US$) in Djibouti in 2011 and the Imports (BoP, current US$) in Myanmar in 2012?
Keep it short and to the point. -8.43e+09. What is the difference between the Imports (BoP, current US$) of Djibouti in 2011 and the Imports (BoP, current US$) of Portugal in 2012?
Make the answer very short. -8.22e+1. What is the difference between the Imports (BoP, current US$) in Lao PDR in 2011 and the Imports (BoP, current US$) in Myanmar in 2012?
Your response must be concise. -6.33e+09. What is the difference between the Imports (BoP, current US$) of Lao PDR in 2011 and the Imports (BoP, current US$) of Portugal in 2012?
Your answer should be compact. -8.01e+1. What is the difference between the Imports (BoP, current US$) of Myanmar in 2011 and the Imports (BoP, current US$) of Portugal in 2012?
Give a very brief answer. -7.43e+1. What is the difference between the Imports (BoP, current US$) in Djibouti in 2011 and the Imports (BoP, current US$) in Lao PDR in 2013?
Give a very brief answer. -2.90e+09. What is the difference between the Imports (BoP, current US$) of Djibouti in 2011 and the Imports (BoP, current US$) of Myanmar in 2013?
Your response must be concise. -1.03e+1. What is the difference between the Imports (BoP, current US$) of Djibouti in 2011 and the Imports (BoP, current US$) of Portugal in 2013?
Your answer should be compact. -8.64e+1. What is the difference between the Imports (BoP, current US$) of Lao PDR in 2011 and the Imports (BoP, current US$) of Myanmar in 2013?
Your response must be concise. -8.19e+09. What is the difference between the Imports (BoP, current US$) of Lao PDR in 2011 and the Imports (BoP, current US$) of Portugal in 2013?
Offer a very short reply. -8.43e+1. What is the difference between the Imports (BoP, current US$) in Myanmar in 2011 and the Imports (BoP, current US$) in Portugal in 2013?
Your answer should be compact. -7.85e+1. What is the difference between the Imports (BoP, current US$) in Djibouti in 2012 and the Imports (BoP, current US$) in Lao PDR in 2013?
Make the answer very short. -2.84e+09. What is the difference between the Imports (BoP, current US$) of Djibouti in 2012 and the Imports (BoP, current US$) of Myanmar in 2013?
Keep it short and to the point. -1.02e+1. What is the difference between the Imports (BoP, current US$) of Djibouti in 2012 and the Imports (BoP, current US$) of Portugal in 2013?
Give a very brief answer. -8.64e+1. What is the difference between the Imports (BoP, current US$) in Lao PDR in 2012 and the Imports (BoP, current US$) in Myanmar in 2013?
Provide a short and direct response. -7.55e+09. What is the difference between the Imports (BoP, current US$) of Lao PDR in 2012 and the Imports (BoP, current US$) of Portugal in 2013?
Make the answer very short. -8.37e+1. What is the difference between the Imports (BoP, current US$) in Myanmar in 2012 and the Imports (BoP, current US$) in Portugal in 2013?
Offer a very short reply. -7.80e+1. What is the average Imports (BoP, current US$) in Djibouti per year?
Your response must be concise. 6.24e+08. What is the average Imports (BoP, current US$) in Lao PDR per year?
Your answer should be very brief. 2.17e+09. What is the average Imports (BoP, current US$) of Myanmar per year?
Ensure brevity in your answer.  5.84e+09. What is the average Imports (BoP, current US$) in Portugal per year?
Offer a very short reply. 8.96e+1. In the year 2006, what is the difference between the Imports (BoP, current US$) of Djibouti and Imports (BoP, current US$) of Lao PDR?
Provide a short and direct response. -6.73e+08. In the year 2006, what is the difference between the Imports (BoP, current US$) in Djibouti and Imports (BoP, current US$) in Myanmar?
Ensure brevity in your answer.  -2.20e+09. In the year 2006, what is the difference between the Imports (BoP, current US$) in Djibouti and Imports (BoP, current US$) in Portugal?
Keep it short and to the point. -7.92e+1. In the year 2006, what is the difference between the Imports (BoP, current US$) in Lao PDR and Imports (BoP, current US$) in Myanmar?
Keep it short and to the point. -1.53e+09. In the year 2006, what is the difference between the Imports (BoP, current US$) in Lao PDR and Imports (BoP, current US$) in Portugal?
Your response must be concise. -7.86e+1. In the year 2006, what is the difference between the Imports (BoP, current US$) in Myanmar and Imports (BoP, current US$) in Portugal?
Provide a short and direct response. -7.70e+1. In the year 2007, what is the difference between the Imports (BoP, current US$) in Djibouti and Imports (BoP, current US$) in Lao PDR?
Ensure brevity in your answer.  -5.40e+08. In the year 2007, what is the difference between the Imports (BoP, current US$) in Djibouti and Imports (BoP, current US$) in Myanmar?
Give a very brief answer. -2.74e+09. In the year 2007, what is the difference between the Imports (BoP, current US$) of Djibouti and Imports (BoP, current US$) of Portugal?
Ensure brevity in your answer.  -9.25e+1. In the year 2007, what is the difference between the Imports (BoP, current US$) in Lao PDR and Imports (BoP, current US$) in Myanmar?
Ensure brevity in your answer.  -2.20e+09. In the year 2007, what is the difference between the Imports (BoP, current US$) in Lao PDR and Imports (BoP, current US$) in Portugal?
Make the answer very short. -9.20e+1. In the year 2007, what is the difference between the Imports (BoP, current US$) in Myanmar and Imports (BoP, current US$) in Portugal?
Your answer should be very brief. -8.98e+1. In the year 2008, what is the difference between the Imports (BoP, current US$) of Djibouti and Imports (BoP, current US$) of Lao PDR?
Your answer should be very brief. -8.20e+08. In the year 2008, what is the difference between the Imports (BoP, current US$) of Djibouti and Imports (BoP, current US$) of Myanmar?
Make the answer very short. -2.89e+09. In the year 2008, what is the difference between the Imports (BoP, current US$) of Djibouti and Imports (BoP, current US$) of Portugal?
Provide a short and direct response. -1.07e+11. In the year 2008, what is the difference between the Imports (BoP, current US$) in Lao PDR and Imports (BoP, current US$) in Myanmar?
Your answer should be compact. -2.07e+09. In the year 2008, what is the difference between the Imports (BoP, current US$) in Lao PDR and Imports (BoP, current US$) in Portugal?
Keep it short and to the point. -1.06e+11. In the year 2008, what is the difference between the Imports (BoP, current US$) in Myanmar and Imports (BoP, current US$) in Portugal?
Make the answer very short. -1.04e+11. In the year 2009, what is the difference between the Imports (BoP, current US$) of Djibouti and Imports (BoP, current US$) of Lao PDR?
Make the answer very short. -1.03e+09. In the year 2009, what is the difference between the Imports (BoP, current US$) of Djibouti and Imports (BoP, current US$) of Myanmar?
Your response must be concise. -3.37e+09. In the year 2009, what is the difference between the Imports (BoP, current US$) of Djibouti and Imports (BoP, current US$) of Portugal?
Offer a terse response. -8.23e+1. In the year 2009, what is the difference between the Imports (BoP, current US$) of Lao PDR and Imports (BoP, current US$) of Myanmar?
Offer a terse response. -2.34e+09. In the year 2009, what is the difference between the Imports (BoP, current US$) of Lao PDR and Imports (BoP, current US$) of Portugal?
Ensure brevity in your answer.  -8.13e+1. In the year 2009, what is the difference between the Imports (BoP, current US$) in Myanmar and Imports (BoP, current US$) in Portugal?
Offer a very short reply. -7.90e+1. In the year 2010, what is the difference between the Imports (BoP, current US$) in Djibouti and Imports (BoP, current US$) in Lao PDR?
Ensure brevity in your answer.  -1.85e+09. In the year 2010, what is the difference between the Imports (BoP, current US$) of Djibouti and Imports (BoP, current US$) of Myanmar?
Provide a succinct answer. -4.17e+09. In the year 2010, what is the difference between the Imports (BoP, current US$) in Djibouti and Imports (BoP, current US$) in Portugal?
Your response must be concise. -8.82e+1. In the year 2010, what is the difference between the Imports (BoP, current US$) of Lao PDR and Imports (BoP, current US$) of Myanmar?
Provide a short and direct response. -2.32e+09. In the year 2010, what is the difference between the Imports (BoP, current US$) of Lao PDR and Imports (BoP, current US$) of Portugal?
Your answer should be compact. -8.64e+1. In the year 2010, what is the difference between the Imports (BoP, current US$) in Myanmar and Imports (BoP, current US$) in Portugal?
Make the answer very short. -8.41e+1. In the year 2011, what is the difference between the Imports (BoP, current US$) in Djibouti and Imports (BoP, current US$) in Lao PDR?
Offer a very short reply. -2.10e+09. In the year 2011, what is the difference between the Imports (BoP, current US$) in Djibouti and Imports (BoP, current US$) in Myanmar?
Offer a very short reply. -7.92e+09. In the year 2011, what is the difference between the Imports (BoP, current US$) of Djibouti and Imports (BoP, current US$) of Portugal?
Give a very brief answer. -9.41e+1. In the year 2011, what is the difference between the Imports (BoP, current US$) of Lao PDR and Imports (BoP, current US$) of Myanmar?
Offer a very short reply. -5.83e+09. In the year 2011, what is the difference between the Imports (BoP, current US$) of Lao PDR and Imports (BoP, current US$) of Portugal?
Give a very brief answer. -9.20e+1. In the year 2011, what is the difference between the Imports (BoP, current US$) of Myanmar and Imports (BoP, current US$) of Portugal?
Your response must be concise. -8.62e+1. In the year 2012, what is the difference between the Imports (BoP, current US$) of Djibouti and Imports (BoP, current US$) of Lao PDR?
Provide a short and direct response. -2.69e+09. In the year 2012, what is the difference between the Imports (BoP, current US$) of Djibouti and Imports (BoP, current US$) of Myanmar?
Make the answer very short. -8.38e+09. In the year 2012, what is the difference between the Imports (BoP, current US$) of Djibouti and Imports (BoP, current US$) of Portugal?
Ensure brevity in your answer.  -8.21e+1. In the year 2012, what is the difference between the Imports (BoP, current US$) in Lao PDR and Imports (BoP, current US$) in Myanmar?
Your response must be concise. -5.69e+09. In the year 2012, what is the difference between the Imports (BoP, current US$) in Lao PDR and Imports (BoP, current US$) in Portugal?
Offer a terse response. -7.94e+1. In the year 2012, what is the difference between the Imports (BoP, current US$) in Myanmar and Imports (BoP, current US$) in Portugal?
Keep it short and to the point. -7.38e+1. In the year 2013, what is the difference between the Imports (BoP, current US$) of Djibouti and Imports (BoP, current US$) of Lao PDR?
Your response must be concise. -2.66e+09. In the year 2013, what is the difference between the Imports (BoP, current US$) of Djibouti and Imports (BoP, current US$) of Myanmar?
Give a very brief answer. -1.00e+1. In the year 2013, what is the difference between the Imports (BoP, current US$) of Djibouti and Imports (BoP, current US$) of Portugal?
Ensure brevity in your answer.  -8.62e+1. In the year 2013, what is the difference between the Imports (BoP, current US$) in Lao PDR and Imports (BoP, current US$) in Myanmar?
Make the answer very short. -7.39e+09. In the year 2013, what is the difference between the Imports (BoP, current US$) in Lao PDR and Imports (BoP, current US$) in Portugal?
Ensure brevity in your answer.  -8.35e+1. In the year 2013, what is the difference between the Imports (BoP, current US$) in Myanmar and Imports (BoP, current US$) in Portugal?
Provide a succinct answer. -7.62e+1. What is the ratio of the Imports (BoP, current US$) of Djibouti in 2006 to that in 2007?
Your answer should be compact. 0.75. What is the ratio of the Imports (BoP, current US$) in Lao PDR in 2006 to that in 2007?
Your response must be concise. 0.99. What is the ratio of the Imports (BoP, current US$) in Myanmar in 2006 to that in 2007?
Keep it short and to the point. 0.79. What is the ratio of the Imports (BoP, current US$) in Portugal in 2006 to that in 2007?
Provide a succinct answer. 0.86. What is the ratio of the Imports (BoP, current US$) in Djibouti in 2006 to that in 2008?
Offer a very short reply. 0.62. What is the ratio of the Imports (BoP, current US$) in Lao PDR in 2006 to that in 2008?
Keep it short and to the point. 0.73. What is the ratio of the Imports (BoP, current US$) of Myanmar in 2006 to that in 2008?
Your answer should be very brief. 0.73. What is the ratio of the Imports (BoP, current US$) of Portugal in 2006 to that in 2008?
Offer a terse response. 0.74. What is the ratio of the Imports (BoP, current US$) of Djibouti in 2006 to that in 2009?
Offer a very short reply. 0.75. What is the ratio of the Imports (BoP, current US$) of Lao PDR in 2006 to that in 2009?
Ensure brevity in your answer.  0.69. What is the ratio of the Imports (BoP, current US$) in Myanmar in 2006 to that in 2009?
Offer a terse response. 0.67. What is the ratio of the Imports (BoP, current US$) of Portugal in 2006 to that in 2009?
Your answer should be compact. 0.96. What is the ratio of the Imports (BoP, current US$) in Djibouti in 2006 to that in 2010?
Your answer should be compact. 0.89. What is the ratio of the Imports (BoP, current US$) in Lao PDR in 2006 to that in 2010?
Provide a short and direct response. 0.47. What is the ratio of the Imports (BoP, current US$) in Myanmar in 2006 to that in 2010?
Provide a succinct answer. 0.57. What is the ratio of the Imports (BoP, current US$) of Portugal in 2006 to that in 2010?
Your answer should be very brief. 0.9. What is the ratio of the Imports (BoP, current US$) of Djibouti in 2006 to that in 2011?
Your answer should be very brief. 0.65. What is the ratio of the Imports (BoP, current US$) of Lao PDR in 2006 to that in 2011?
Give a very brief answer. 0.4. What is the ratio of the Imports (BoP, current US$) in Myanmar in 2006 to that in 2011?
Your response must be concise. 0.31. What is the ratio of the Imports (BoP, current US$) in Portugal in 2006 to that in 2011?
Your answer should be very brief. 0.84. What is the ratio of the Imports (BoP, current US$) in Djibouti in 2006 to that in 2012?
Keep it short and to the point. 0.6. What is the ratio of the Imports (BoP, current US$) of Lao PDR in 2006 to that in 2012?
Offer a terse response. 0.32. What is the ratio of the Imports (BoP, current US$) in Myanmar in 2006 to that in 2012?
Offer a terse response. 0.29. What is the ratio of the Imports (BoP, current US$) in Portugal in 2006 to that in 2012?
Keep it short and to the point. 0.96. What is the ratio of the Imports (BoP, current US$) in Djibouti in 2006 to that in 2013?
Give a very brief answer. 0.47. What is the ratio of the Imports (BoP, current US$) of Lao PDR in 2006 to that in 2013?
Make the answer very short. 0.31. What is the ratio of the Imports (BoP, current US$) in Myanmar in 2006 to that in 2013?
Your answer should be compact. 0.24. What is the ratio of the Imports (BoP, current US$) in Portugal in 2006 to that in 2013?
Keep it short and to the point. 0.91. What is the ratio of the Imports (BoP, current US$) in Djibouti in 2007 to that in 2008?
Provide a succinct answer. 0.82. What is the ratio of the Imports (BoP, current US$) of Lao PDR in 2007 to that in 2008?
Offer a terse response. 0.73. What is the ratio of the Imports (BoP, current US$) in Myanmar in 2007 to that in 2008?
Keep it short and to the point. 0.92. What is the ratio of the Imports (BoP, current US$) of Portugal in 2007 to that in 2008?
Your answer should be compact. 0.87. What is the ratio of the Imports (BoP, current US$) in Lao PDR in 2007 to that in 2009?
Your answer should be compact. 0.69. What is the ratio of the Imports (BoP, current US$) in Myanmar in 2007 to that in 2009?
Offer a terse response. 0.84. What is the ratio of the Imports (BoP, current US$) of Portugal in 2007 to that in 2009?
Your answer should be very brief. 1.12. What is the ratio of the Imports (BoP, current US$) in Djibouti in 2007 to that in 2010?
Provide a succinct answer. 1.19. What is the ratio of the Imports (BoP, current US$) in Lao PDR in 2007 to that in 2010?
Your answer should be very brief. 0.48. What is the ratio of the Imports (BoP, current US$) of Myanmar in 2007 to that in 2010?
Ensure brevity in your answer.  0.71. What is the ratio of the Imports (BoP, current US$) in Portugal in 2007 to that in 2010?
Your answer should be very brief. 1.05. What is the ratio of the Imports (BoP, current US$) in Djibouti in 2007 to that in 2011?
Provide a short and direct response. 0.86. What is the ratio of the Imports (BoP, current US$) in Lao PDR in 2007 to that in 2011?
Make the answer very short. 0.4. What is the ratio of the Imports (BoP, current US$) of Myanmar in 2007 to that in 2011?
Ensure brevity in your answer.  0.39. What is the ratio of the Imports (BoP, current US$) of Djibouti in 2007 to that in 2012?
Provide a succinct answer. 0.8. What is the ratio of the Imports (BoP, current US$) in Lao PDR in 2007 to that in 2012?
Give a very brief answer. 0.33. What is the ratio of the Imports (BoP, current US$) of Myanmar in 2007 to that in 2012?
Your answer should be compact. 0.36. What is the ratio of the Imports (BoP, current US$) of Portugal in 2007 to that in 2012?
Your answer should be very brief. 1.12. What is the ratio of the Imports (BoP, current US$) in Djibouti in 2007 to that in 2013?
Keep it short and to the point. 0.63. What is the ratio of the Imports (BoP, current US$) of Lao PDR in 2007 to that in 2013?
Your answer should be very brief. 0.31. What is the ratio of the Imports (BoP, current US$) in Myanmar in 2007 to that in 2013?
Make the answer very short. 0.3. What is the ratio of the Imports (BoP, current US$) of Portugal in 2007 to that in 2013?
Give a very brief answer. 1.07. What is the ratio of the Imports (BoP, current US$) of Djibouti in 2008 to that in 2009?
Your answer should be compact. 1.22. What is the ratio of the Imports (BoP, current US$) in Lao PDR in 2008 to that in 2009?
Offer a terse response. 0.95. What is the ratio of the Imports (BoP, current US$) of Myanmar in 2008 to that in 2009?
Keep it short and to the point. 0.91. What is the ratio of the Imports (BoP, current US$) of Portugal in 2008 to that in 2009?
Your answer should be compact. 1.3. What is the ratio of the Imports (BoP, current US$) of Djibouti in 2008 to that in 2010?
Keep it short and to the point. 1.44. What is the ratio of the Imports (BoP, current US$) of Lao PDR in 2008 to that in 2010?
Provide a succinct answer. 0.65. What is the ratio of the Imports (BoP, current US$) in Myanmar in 2008 to that in 2010?
Your answer should be compact. 0.77. What is the ratio of the Imports (BoP, current US$) in Portugal in 2008 to that in 2010?
Ensure brevity in your answer.  1.21. What is the ratio of the Imports (BoP, current US$) in Djibouti in 2008 to that in 2011?
Provide a succinct answer. 1.05. What is the ratio of the Imports (BoP, current US$) in Lao PDR in 2008 to that in 2011?
Keep it short and to the point. 0.55. What is the ratio of the Imports (BoP, current US$) of Myanmar in 2008 to that in 2011?
Make the answer very short. 0.42. What is the ratio of the Imports (BoP, current US$) in Portugal in 2008 to that in 2011?
Provide a short and direct response. 1.14. What is the ratio of the Imports (BoP, current US$) in Djibouti in 2008 to that in 2012?
Ensure brevity in your answer.  0.97. What is the ratio of the Imports (BoP, current US$) of Lao PDR in 2008 to that in 2012?
Ensure brevity in your answer.  0.45. What is the ratio of the Imports (BoP, current US$) in Myanmar in 2008 to that in 2012?
Provide a succinct answer. 0.39. What is the ratio of the Imports (BoP, current US$) in Portugal in 2008 to that in 2012?
Ensure brevity in your answer.  1.3. What is the ratio of the Imports (BoP, current US$) of Djibouti in 2008 to that in 2013?
Keep it short and to the point. 0.77. What is the ratio of the Imports (BoP, current US$) of Lao PDR in 2008 to that in 2013?
Your answer should be compact. 0.43. What is the ratio of the Imports (BoP, current US$) in Myanmar in 2008 to that in 2013?
Offer a terse response. 0.33. What is the ratio of the Imports (BoP, current US$) in Portugal in 2008 to that in 2013?
Ensure brevity in your answer.  1.24. What is the ratio of the Imports (BoP, current US$) of Djibouti in 2009 to that in 2010?
Your response must be concise. 1.18. What is the ratio of the Imports (BoP, current US$) in Lao PDR in 2009 to that in 2010?
Your response must be concise. 0.69. What is the ratio of the Imports (BoP, current US$) in Myanmar in 2009 to that in 2010?
Make the answer very short. 0.85. What is the ratio of the Imports (BoP, current US$) in Portugal in 2009 to that in 2010?
Your answer should be very brief. 0.93. What is the ratio of the Imports (BoP, current US$) in Djibouti in 2009 to that in 2011?
Make the answer very short. 0.86. What is the ratio of the Imports (BoP, current US$) in Lao PDR in 2009 to that in 2011?
Ensure brevity in your answer.  0.58. What is the ratio of the Imports (BoP, current US$) in Myanmar in 2009 to that in 2011?
Make the answer very short. 0.46. What is the ratio of the Imports (BoP, current US$) of Portugal in 2009 to that in 2011?
Keep it short and to the point. 0.87. What is the ratio of the Imports (BoP, current US$) in Djibouti in 2009 to that in 2012?
Make the answer very short. 0.8. What is the ratio of the Imports (BoP, current US$) in Lao PDR in 2009 to that in 2012?
Offer a terse response. 0.47. What is the ratio of the Imports (BoP, current US$) in Myanmar in 2009 to that in 2012?
Ensure brevity in your answer.  0.43. What is the ratio of the Imports (BoP, current US$) of Portugal in 2009 to that in 2012?
Ensure brevity in your answer.  1. What is the ratio of the Imports (BoP, current US$) of Djibouti in 2009 to that in 2013?
Your answer should be compact. 0.63. What is the ratio of the Imports (BoP, current US$) of Lao PDR in 2009 to that in 2013?
Provide a succinct answer. 0.45. What is the ratio of the Imports (BoP, current US$) in Myanmar in 2009 to that in 2013?
Your answer should be very brief. 0.36. What is the ratio of the Imports (BoP, current US$) in Portugal in 2009 to that in 2013?
Provide a short and direct response. 0.95. What is the ratio of the Imports (BoP, current US$) in Djibouti in 2010 to that in 2011?
Keep it short and to the point. 0.73. What is the ratio of the Imports (BoP, current US$) in Lao PDR in 2010 to that in 2011?
Your response must be concise. 0.84. What is the ratio of the Imports (BoP, current US$) in Myanmar in 2010 to that in 2011?
Offer a very short reply. 0.54. What is the ratio of the Imports (BoP, current US$) in Portugal in 2010 to that in 2011?
Make the answer very short. 0.94. What is the ratio of the Imports (BoP, current US$) of Djibouti in 2010 to that in 2012?
Your answer should be very brief. 0.67. What is the ratio of the Imports (BoP, current US$) of Lao PDR in 2010 to that in 2012?
Your response must be concise. 0.68. What is the ratio of the Imports (BoP, current US$) in Myanmar in 2010 to that in 2012?
Offer a terse response. 0.51. What is the ratio of the Imports (BoP, current US$) of Portugal in 2010 to that in 2012?
Your answer should be compact. 1.07. What is the ratio of the Imports (BoP, current US$) of Djibouti in 2010 to that in 2013?
Your answer should be very brief. 0.53. What is the ratio of the Imports (BoP, current US$) in Lao PDR in 2010 to that in 2013?
Your answer should be compact. 0.65. What is the ratio of the Imports (BoP, current US$) of Myanmar in 2010 to that in 2013?
Your response must be concise. 0.42. What is the ratio of the Imports (BoP, current US$) of Portugal in 2010 to that in 2013?
Provide a succinct answer. 1.02. What is the ratio of the Imports (BoP, current US$) of Djibouti in 2011 to that in 2012?
Provide a short and direct response. 0.93. What is the ratio of the Imports (BoP, current US$) of Lao PDR in 2011 to that in 2012?
Provide a succinct answer. 0.81. What is the ratio of the Imports (BoP, current US$) of Myanmar in 2011 to that in 2012?
Provide a short and direct response. 0.94. What is the ratio of the Imports (BoP, current US$) of Portugal in 2011 to that in 2012?
Ensure brevity in your answer.  1.14. What is the ratio of the Imports (BoP, current US$) of Djibouti in 2011 to that in 2013?
Give a very brief answer. 0.73. What is the ratio of the Imports (BoP, current US$) in Lao PDR in 2011 to that in 2013?
Ensure brevity in your answer.  0.77. What is the ratio of the Imports (BoP, current US$) in Myanmar in 2011 to that in 2013?
Ensure brevity in your answer.  0.78. What is the ratio of the Imports (BoP, current US$) in Portugal in 2011 to that in 2013?
Your response must be concise. 1.09. What is the ratio of the Imports (BoP, current US$) in Djibouti in 2012 to that in 2013?
Offer a very short reply. 0.79. What is the ratio of the Imports (BoP, current US$) of Lao PDR in 2012 to that in 2013?
Give a very brief answer. 0.96. What is the ratio of the Imports (BoP, current US$) in Myanmar in 2012 to that in 2013?
Offer a very short reply. 0.83. What is the ratio of the Imports (BoP, current US$) in Portugal in 2012 to that in 2013?
Provide a short and direct response. 0.95. What is the difference between the highest and the second highest Imports (BoP, current US$) in Djibouti?
Provide a short and direct response. 1.88e+08. What is the difference between the highest and the second highest Imports (BoP, current US$) of Lao PDR?
Provide a succinct answer. 1.59e+08. What is the difference between the highest and the second highest Imports (BoP, current US$) of Myanmar?
Ensure brevity in your answer.  1.86e+09. What is the difference between the highest and the second highest Imports (BoP, current US$) of Portugal?
Provide a short and direct response. 1.28e+1. What is the difference between the highest and the lowest Imports (BoP, current US$) in Djibouti?
Your response must be concise. 4.73e+08. What is the difference between the highest and the lowest Imports (BoP, current US$) in Lao PDR?
Make the answer very short. 2.46e+09. What is the difference between the highest and the lowest Imports (BoP, current US$) of Myanmar?
Keep it short and to the point. 8.32e+09. What is the difference between the highest and the lowest Imports (BoP, current US$) of Portugal?
Offer a very short reply. 2.79e+1. 